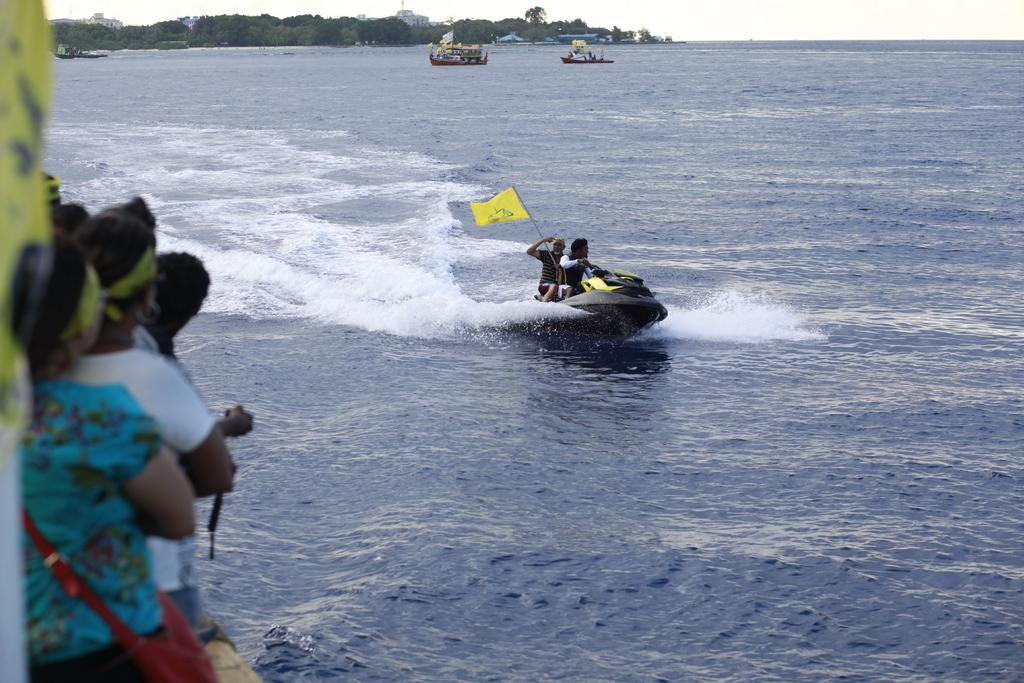In one or two sentences, can you explain what this image depicts? In this image we can see a jet ski. On the jet ski we can see two persons and a flag. There are few boats in the water. Behind the water we can see a group of trees and buildings. On the left side, we can see few persons. At the top we can see the sky. 